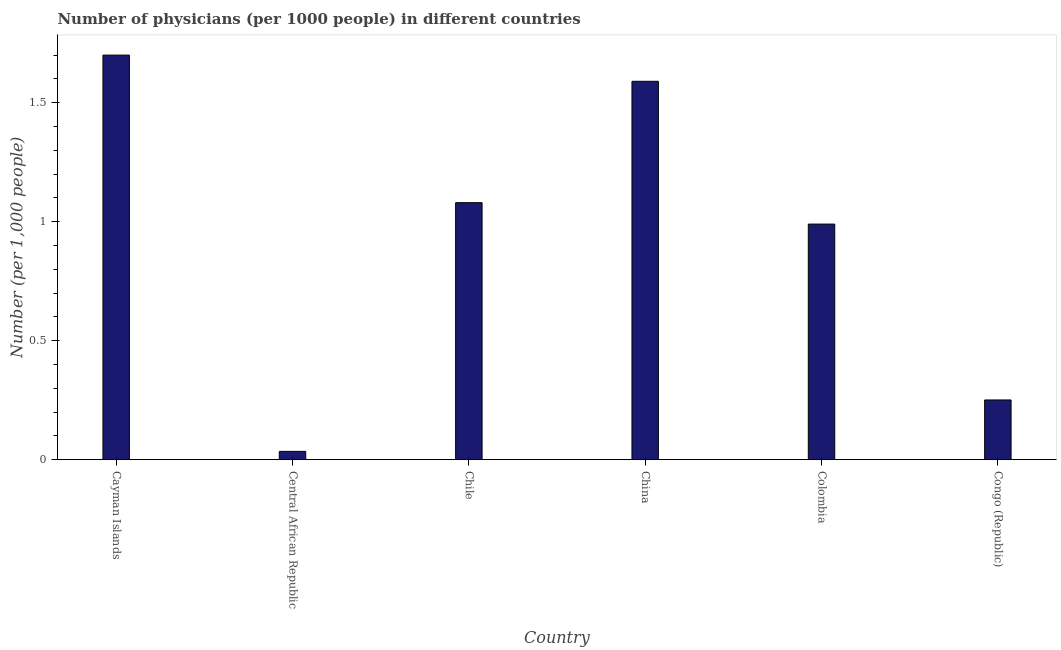Does the graph contain grids?
Offer a terse response. No. What is the title of the graph?
Your response must be concise. Number of physicians (per 1000 people) in different countries. What is the label or title of the X-axis?
Provide a short and direct response. Country. What is the label or title of the Y-axis?
Give a very brief answer. Number (per 1,0 people). What is the number of physicians in Cayman Islands?
Provide a short and direct response. 1.7. Across all countries, what is the minimum number of physicians?
Provide a short and direct response. 0.04. In which country was the number of physicians maximum?
Your answer should be very brief. Cayman Islands. In which country was the number of physicians minimum?
Keep it short and to the point. Central African Republic. What is the sum of the number of physicians?
Keep it short and to the point. 5.65. What is the difference between the number of physicians in Central African Republic and China?
Your answer should be compact. -1.55. What is the average number of physicians per country?
Keep it short and to the point. 0.94. What is the median number of physicians?
Provide a succinct answer. 1.04. What is the ratio of the number of physicians in Cayman Islands to that in Central African Republic?
Your answer should be very brief. 48.57. Is the number of physicians in Colombia less than that in Congo (Republic)?
Make the answer very short. No. What is the difference between the highest and the second highest number of physicians?
Ensure brevity in your answer.  0.11. What is the difference between the highest and the lowest number of physicians?
Offer a terse response. 1.67. How many countries are there in the graph?
Ensure brevity in your answer.  6. What is the Number (per 1,000 people) of Central African Republic?
Offer a very short reply. 0.04. What is the Number (per 1,000 people) of China?
Give a very brief answer. 1.59. What is the Number (per 1,000 people) in Colombia?
Your answer should be compact. 0.99. What is the Number (per 1,000 people) in Congo (Republic)?
Your answer should be very brief. 0.25. What is the difference between the Number (per 1,000 people) in Cayman Islands and Central African Republic?
Make the answer very short. 1.67. What is the difference between the Number (per 1,000 people) in Cayman Islands and Chile?
Provide a succinct answer. 0.62. What is the difference between the Number (per 1,000 people) in Cayman Islands and China?
Give a very brief answer. 0.11. What is the difference between the Number (per 1,000 people) in Cayman Islands and Colombia?
Provide a succinct answer. 0.71. What is the difference between the Number (per 1,000 people) in Cayman Islands and Congo (Republic)?
Make the answer very short. 1.45. What is the difference between the Number (per 1,000 people) in Central African Republic and Chile?
Offer a terse response. -1.04. What is the difference between the Number (per 1,000 people) in Central African Republic and China?
Make the answer very short. -1.55. What is the difference between the Number (per 1,000 people) in Central African Republic and Colombia?
Offer a terse response. -0.95. What is the difference between the Number (per 1,000 people) in Central African Republic and Congo (Republic)?
Make the answer very short. -0.22. What is the difference between the Number (per 1,000 people) in Chile and China?
Keep it short and to the point. -0.51. What is the difference between the Number (per 1,000 people) in Chile and Colombia?
Offer a very short reply. 0.09. What is the difference between the Number (per 1,000 people) in Chile and Congo (Republic)?
Ensure brevity in your answer.  0.83. What is the difference between the Number (per 1,000 people) in China and Colombia?
Offer a very short reply. 0.6. What is the difference between the Number (per 1,000 people) in China and Congo (Republic)?
Your response must be concise. 1.34. What is the difference between the Number (per 1,000 people) in Colombia and Congo (Republic)?
Give a very brief answer. 0.74. What is the ratio of the Number (per 1,000 people) in Cayman Islands to that in Central African Republic?
Provide a short and direct response. 48.57. What is the ratio of the Number (per 1,000 people) in Cayman Islands to that in Chile?
Keep it short and to the point. 1.57. What is the ratio of the Number (per 1,000 people) in Cayman Islands to that in China?
Your answer should be compact. 1.07. What is the ratio of the Number (per 1,000 people) in Cayman Islands to that in Colombia?
Provide a short and direct response. 1.72. What is the ratio of the Number (per 1,000 people) in Cayman Islands to that in Congo (Republic)?
Make the answer very short. 6.77. What is the ratio of the Number (per 1,000 people) in Central African Republic to that in Chile?
Ensure brevity in your answer.  0.03. What is the ratio of the Number (per 1,000 people) in Central African Republic to that in China?
Give a very brief answer. 0.02. What is the ratio of the Number (per 1,000 people) in Central African Republic to that in Colombia?
Make the answer very short. 0.04. What is the ratio of the Number (per 1,000 people) in Central African Republic to that in Congo (Republic)?
Make the answer very short. 0.14. What is the ratio of the Number (per 1,000 people) in Chile to that in China?
Give a very brief answer. 0.68. What is the ratio of the Number (per 1,000 people) in Chile to that in Colombia?
Your answer should be very brief. 1.09. What is the ratio of the Number (per 1,000 people) in Chile to that in Congo (Republic)?
Ensure brevity in your answer.  4.3. What is the ratio of the Number (per 1,000 people) in China to that in Colombia?
Make the answer very short. 1.61. What is the ratio of the Number (per 1,000 people) in China to that in Congo (Republic)?
Provide a short and direct response. 6.33. What is the ratio of the Number (per 1,000 people) in Colombia to that in Congo (Republic)?
Keep it short and to the point. 3.94. 